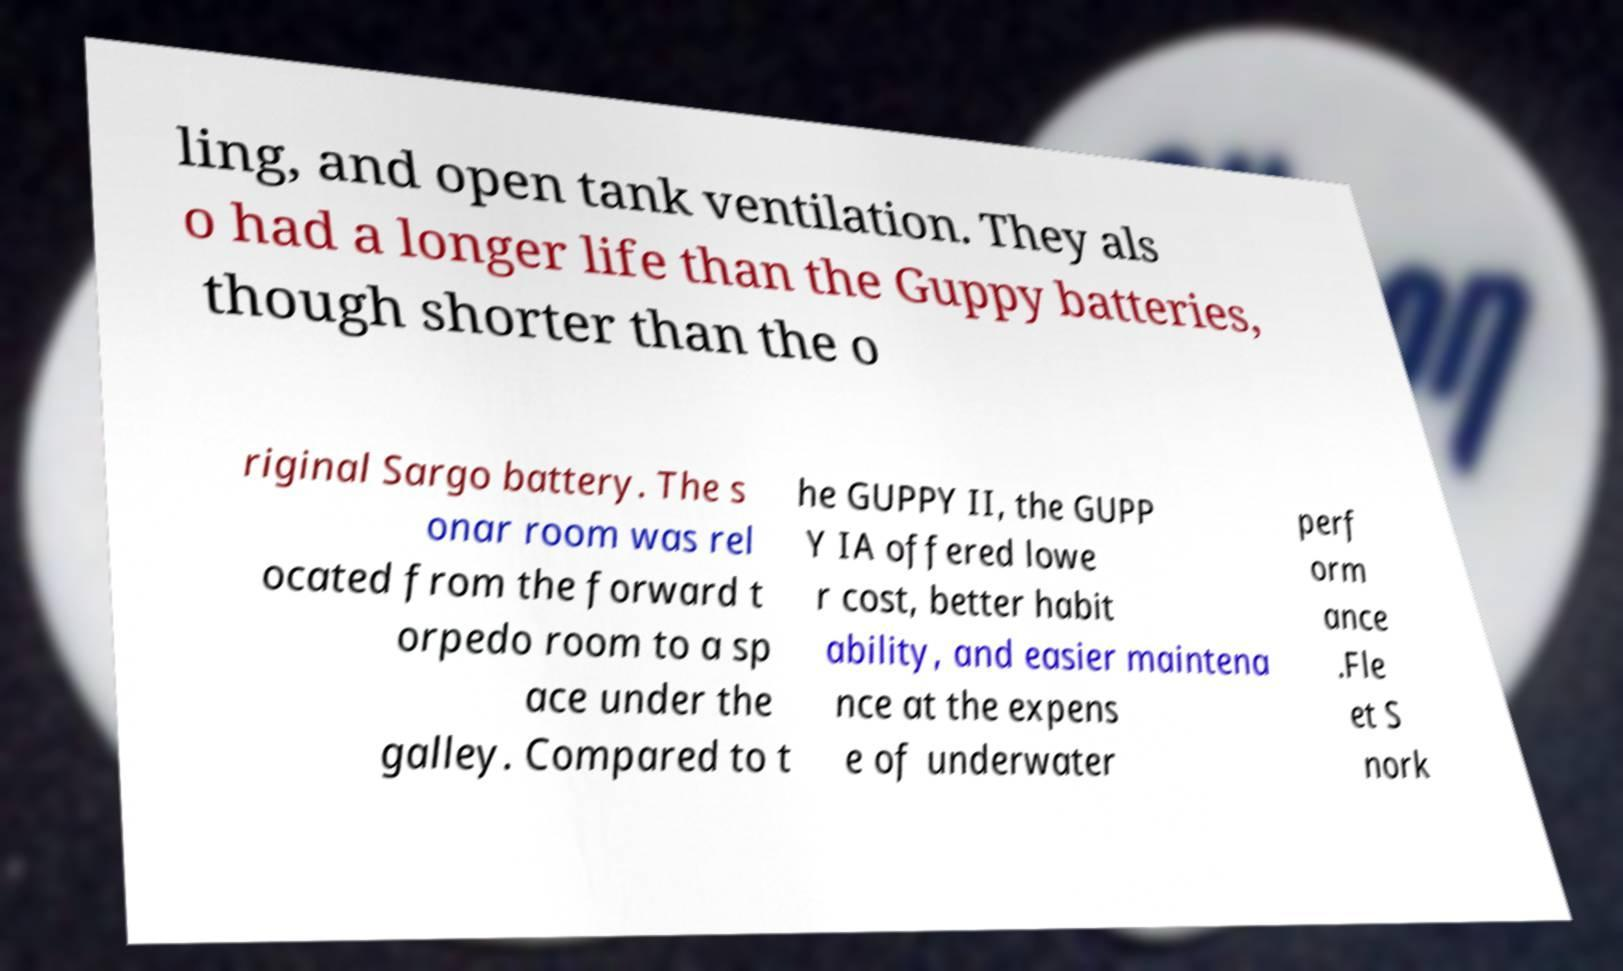Could you extract and type out the text from this image? ling, and open tank ventilation. They als o had a longer life than the Guppy batteries, though shorter than the o riginal Sargo battery. The s onar room was rel ocated from the forward t orpedo room to a sp ace under the galley. Compared to t he GUPPY II, the GUPP Y IA offered lowe r cost, better habit ability, and easier maintena nce at the expens e of underwater perf orm ance .Fle et S nork 